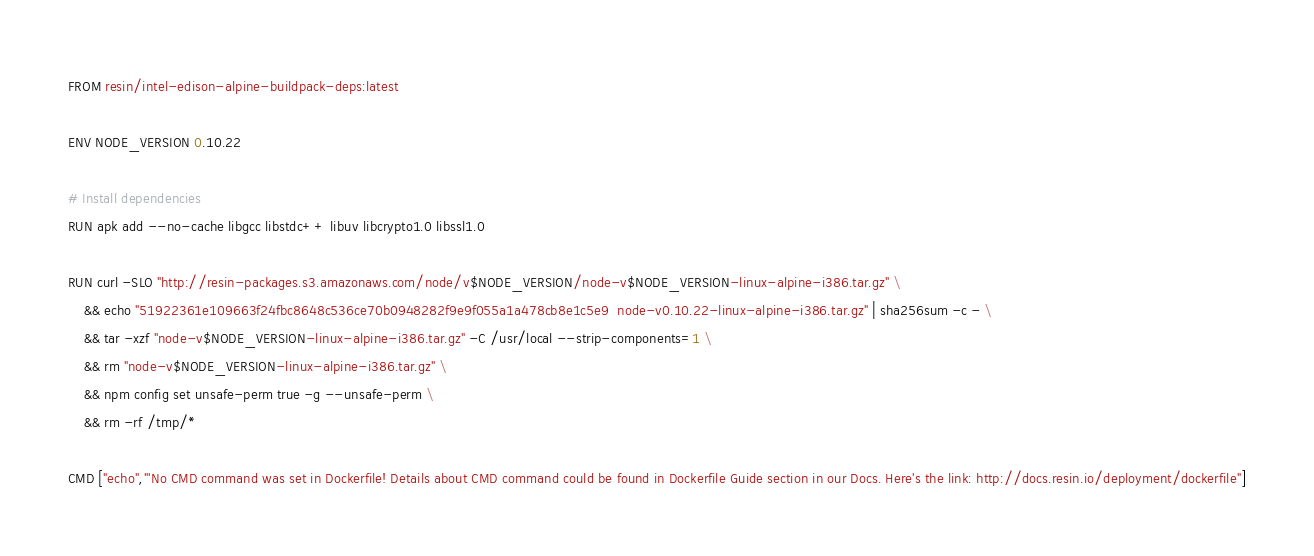<code> <loc_0><loc_0><loc_500><loc_500><_Dockerfile_>FROM resin/intel-edison-alpine-buildpack-deps:latest

ENV NODE_VERSION 0.10.22

# Install dependencies
RUN apk add --no-cache libgcc libstdc++ libuv libcrypto1.0 libssl1.0

RUN curl -SLO "http://resin-packages.s3.amazonaws.com/node/v$NODE_VERSION/node-v$NODE_VERSION-linux-alpine-i386.tar.gz" \
	&& echo "51922361e109663f24fbc8648c536ce70b0948282f9e9f055a1a478cb8e1c5e9  node-v0.10.22-linux-alpine-i386.tar.gz" | sha256sum -c - \
	&& tar -xzf "node-v$NODE_VERSION-linux-alpine-i386.tar.gz" -C /usr/local --strip-components=1 \
	&& rm "node-v$NODE_VERSION-linux-alpine-i386.tar.gz" \
	&& npm config set unsafe-perm true -g --unsafe-perm \
	&& rm -rf /tmp/*

CMD ["echo","'No CMD command was set in Dockerfile! Details about CMD command could be found in Dockerfile Guide section in our Docs. Here's the link: http://docs.resin.io/deployment/dockerfile"]
</code> 